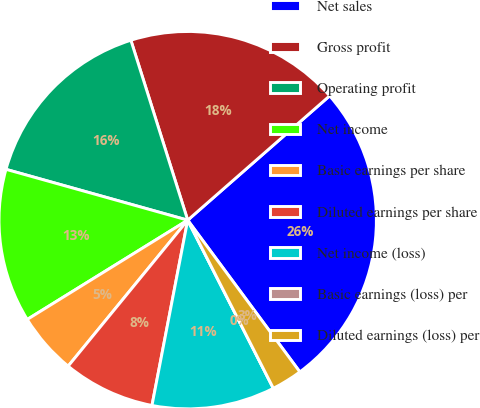<chart> <loc_0><loc_0><loc_500><loc_500><pie_chart><fcel>Net sales<fcel>Gross profit<fcel>Operating profit<fcel>Net income<fcel>Basic earnings per share<fcel>Diluted earnings per share<fcel>Net income (loss)<fcel>Basic earnings (loss) per<fcel>Diluted earnings (loss) per<nl><fcel>26.32%<fcel>18.42%<fcel>15.79%<fcel>13.16%<fcel>5.26%<fcel>7.89%<fcel>10.53%<fcel>0.0%<fcel>2.63%<nl></chart> 